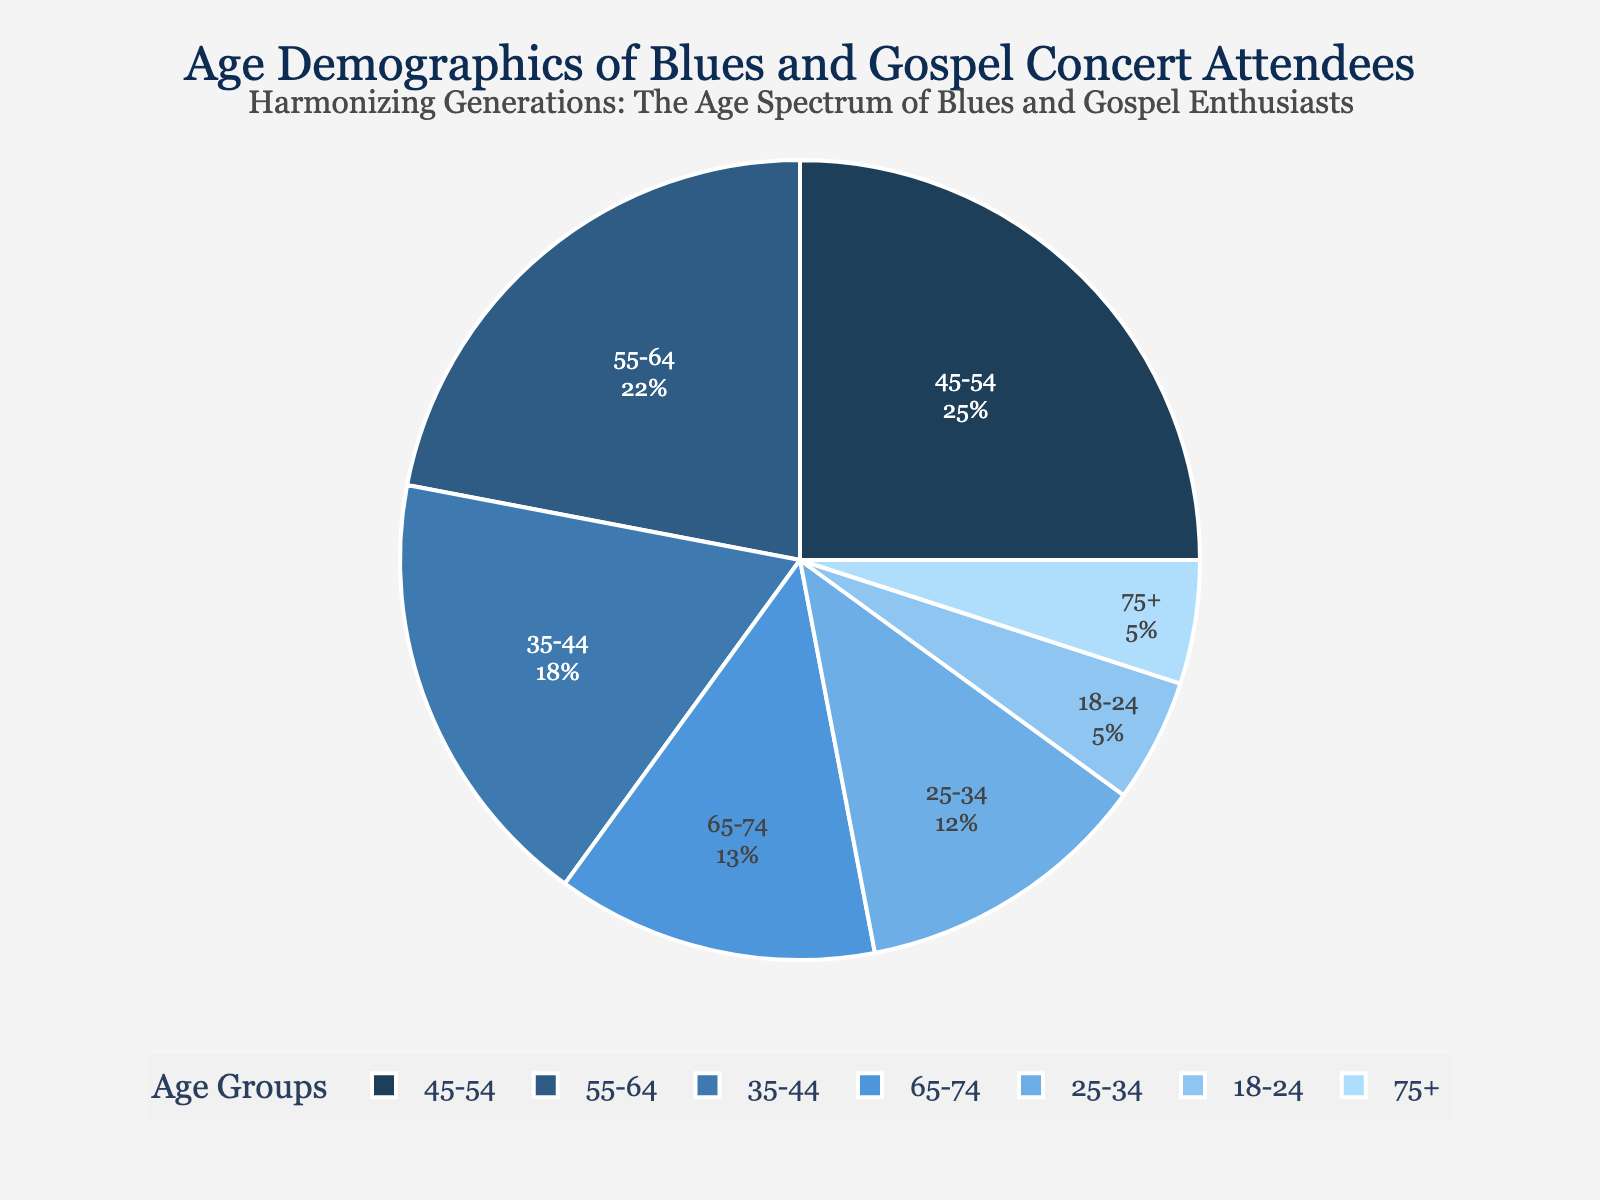What age group forms the largest percentage of attendees? The largest slice in the pie chart corresponds to the age group 45-54. By observing the labelled percentages within the slices, we see that the group 45-54 has the highest percentage at 25%.
Answer: 45-54 What is the combined percentage of attendees aged 55 and older? We need to add the percentages of the age groups 55-64, 65-74, and 75+. In the pie chart, these percentages are 22%, 13%, and 5%. Adding these together: 22 + 13 + 5 = 40%.
Answer: 40% How does the percentage of attendees aged 25-34 compare to those aged 35-44? By comparing the slices corresponding to 25-34 and 35-44, we see that the 35-44 age group has a larger percentage. The chart shows 12% for 25-34 and 18% for 35-44.
Answer: 35-44 is larger Which age groups make up the smallest and largest percentages of attendees? By observing the pie chart, start with identifying the smallest and largest slices. The 18-24 and 75+ age groups form the smallest percentages, each at 5%. The largest percentage is the 45-54 age group at 25%.
Answer: 18-24 and 75+ (smallest), 45-54 (largest) What is the average percentage of attendees in the age groups from 25-34 to 65-74? First, sum the percentages of the age groups from 25-34 to 65-74, which are 12%, 18%, 25%, 22%, and 13%. The total is 12 + 18 + 25 + 22 + 13 = 90%. Divide this sum by the number of age groups, which is 5: 90 / 5 = 18%.
Answer: 18% What is the difference in percentage between the oldest age group (75+) and the 45-54 age group? Subtract the percentage of the oldest age group (75%) from the percentage of the 45-54 age group. The pie chart shows 25% for 45-54 and 5% for 75+: 25 - 5 = 20%.
Answer: 20% What is the ratio of attendees aged 35-44 to those aged 18-24? The percentage for 35-44 is 18%, and for 18-24 it is 5%. To find the ratio, we divide 18 by 5, which simplifies to 3.6.
Answer: 3.6:1 Which colors represent the 55-64 and 65-74 age groups? According to the color palette inspired by blues and gospel, the 55-64 age group is represented by a lighter blue shade and the 65-74 age group is slightly darker blue than 55-64. By comparing the legend and slices, these shades can be identified.
Answer: Light blue (55-64), slightly darker blue (65-74) 